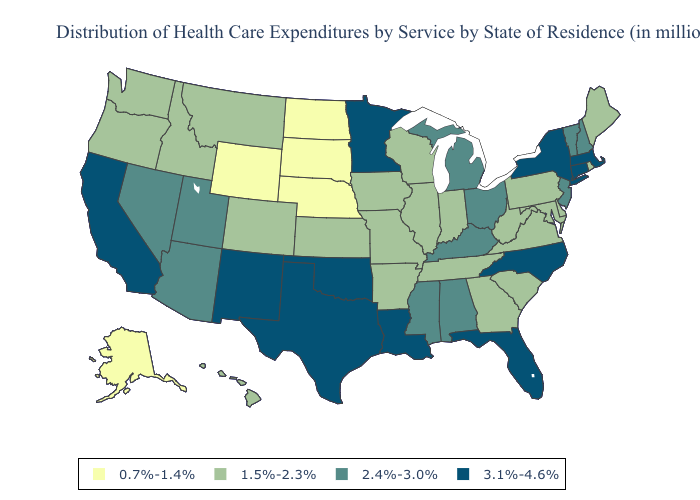Name the states that have a value in the range 2.4%-3.0%?
Answer briefly. Alabama, Arizona, Kentucky, Michigan, Mississippi, Nevada, New Hampshire, New Jersey, Ohio, Utah, Vermont. Does the first symbol in the legend represent the smallest category?
Be succinct. Yes. Name the states that have a value in the range 1.5%-2.3%?
Be succinct. Arkansas, Colorado, Delaware, Georgia, Hawaii, Idaho, Illinois, Indiana, Iowa, Kansas, Maine, Maryland, Missouri, Montana, Oregon, Pennsylvania, Rhode Island, South Carolina, Tennessee, Virginia, Washington, West Virginia, Wisconsin. Does Mississippi have the lowest value in the USA?
Concise answer only. No. Is the legend a continuous bar?
Give a very brief answer. No. Is the legend a continuous bar?
Be succinct. No. Name the states that have a value in the range 2.4%-3.0%?
Give a very brief answer. Alabama, Arizona, Kentucky, Michigan, Mississippi, Nevada, New Hampshire, New Jersey, Ohio, Utah, Vermont. Which states have the lowest value in the MidWest?
Write a very short answer. Nebraska, North Dakota, South Dakota. Does Maryland have the lowest value in the South?
Write a very short answer. Yes. Name the states that have a value in the range 0.7%-1.4%?
Write a very short answer. Alaska, Nebraska, North Dakota, South Dakota, Wyoming. What is the lowest value in states that border Vermont?
Write a very short answer. 2.4%-3.0%. What is the lowest value in states that border Arizona?
Give a very brief answer. 1.5%-2.3%. Which states have the highest value in the USA?
Quick response, please. California, Connecticut, Florida, Louisiana, Massachusetts, Minnesota, New Mexico, New York, North Carolina, Oklahoma, Texas. 